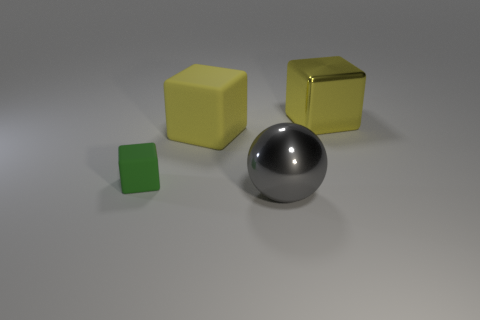Are there any yellow metal blocks in front of the yellow metallic thing? Yes, there is one yellow metal block positioned to the front left side of the spherical metallic object, which could be considered 'in front' depending on your perspective. 